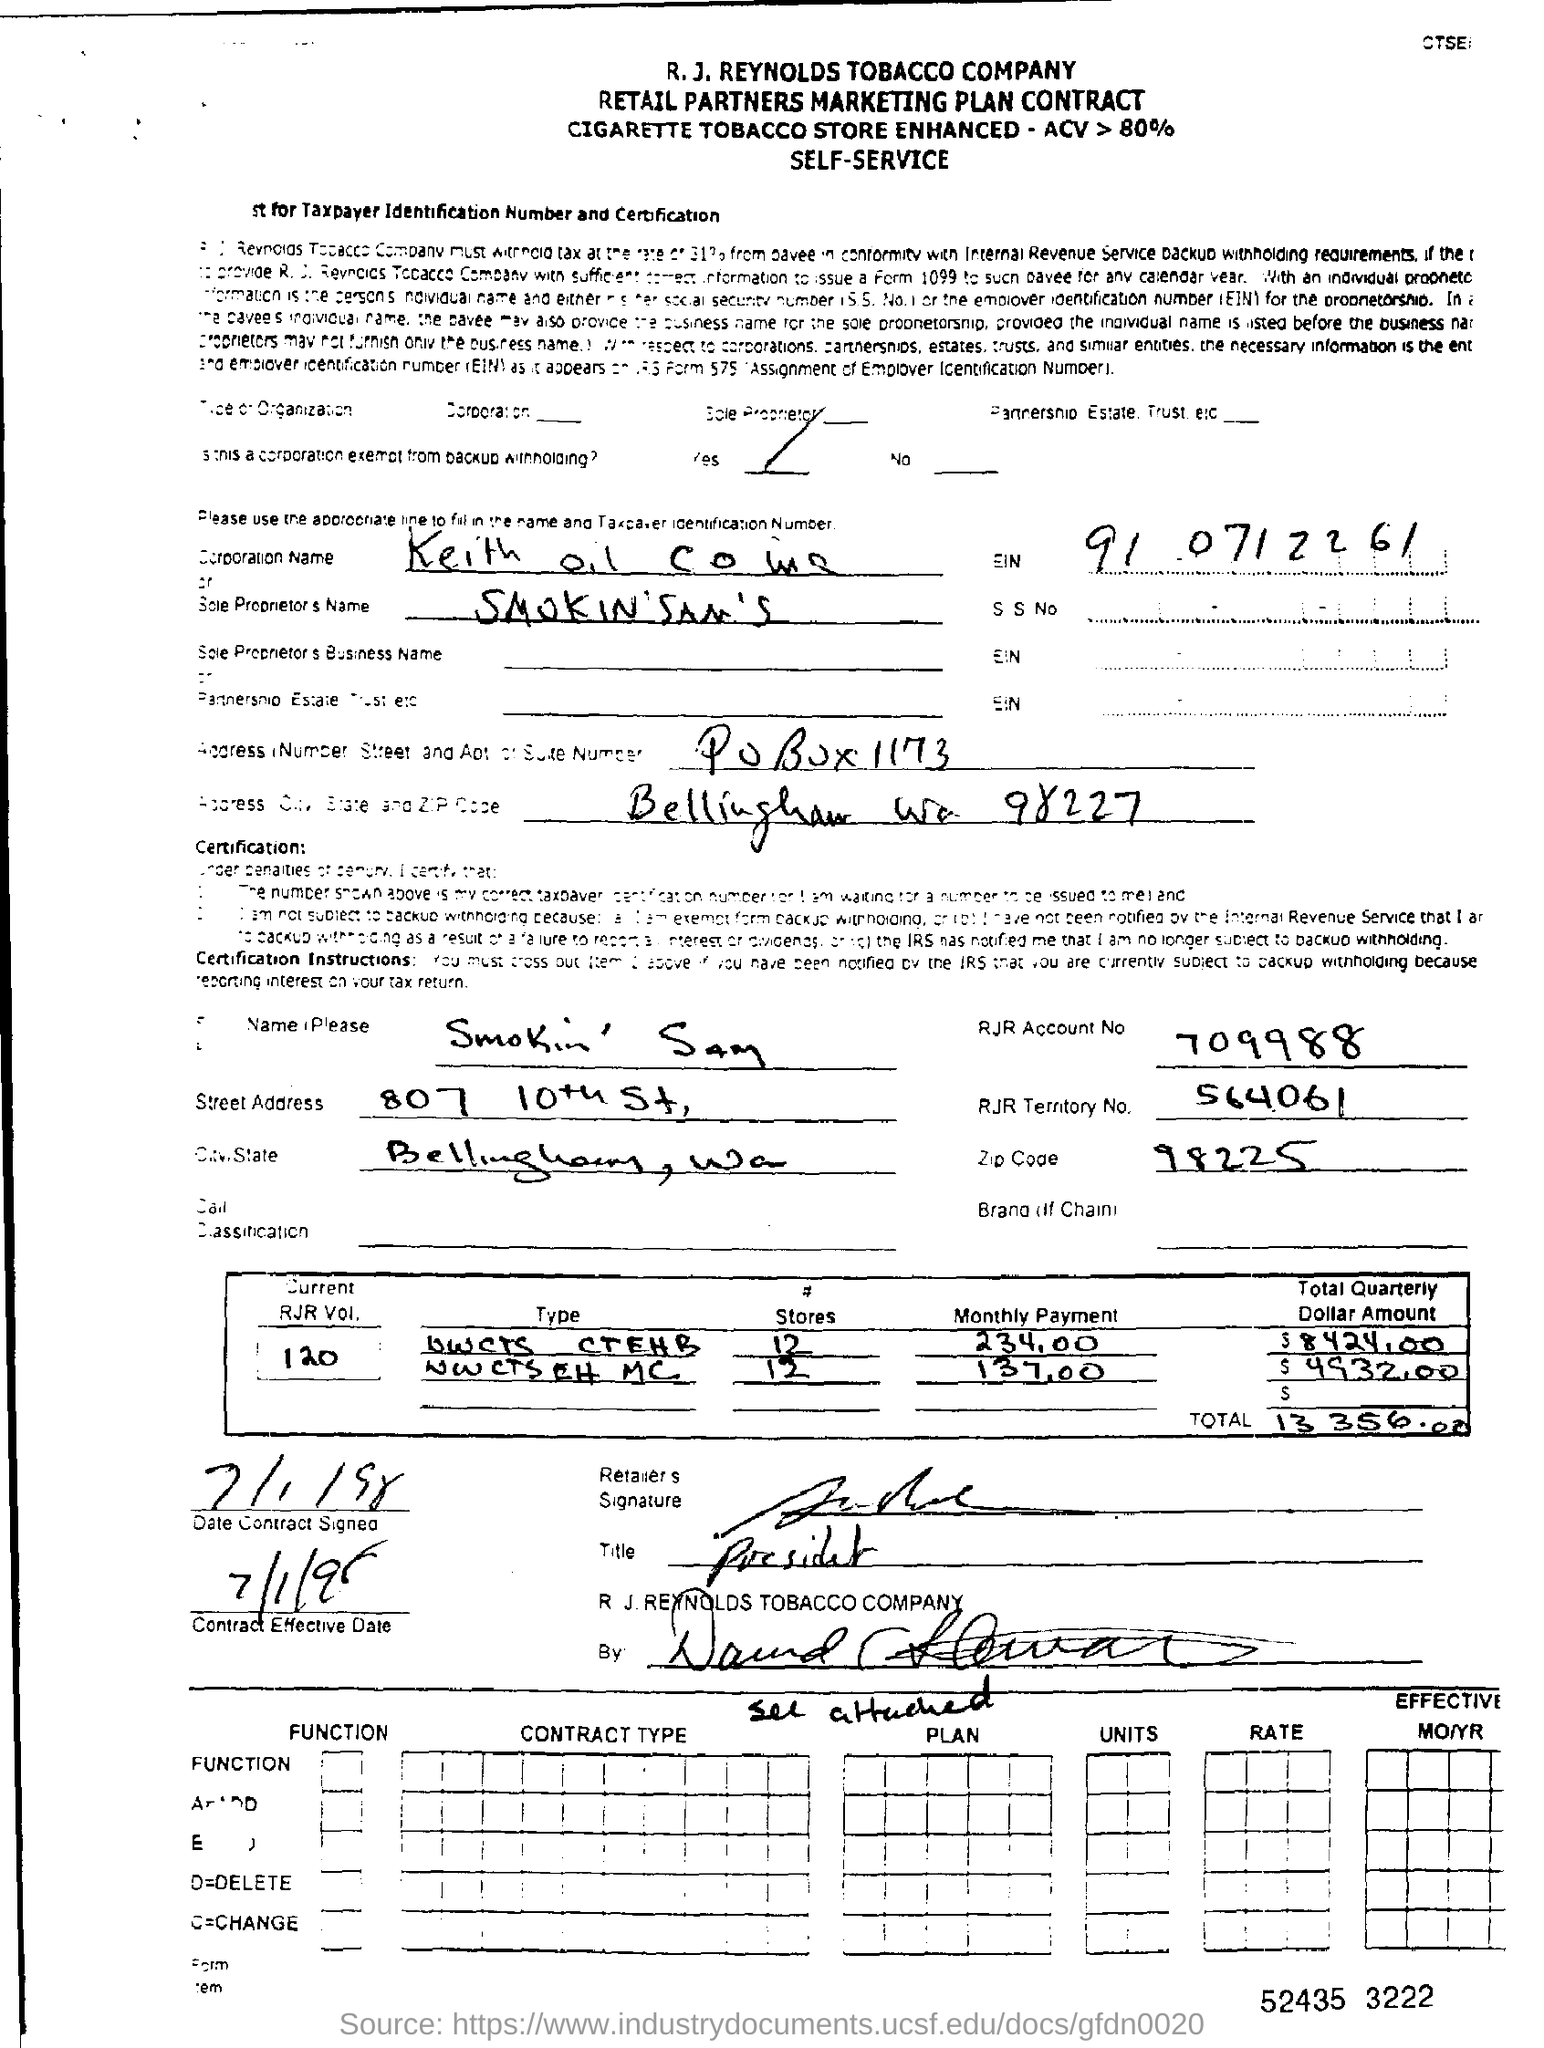What type of contract is this?
Provide a succinct answer. RETAIL PARTNERS MARKETING PLAN CONTRACT. What is the RJR Account No mentioned in the contract form?
Your answer should be very brief. 709988. What is the RJR territory No. mentioned in the contract form?
Your response must be concise. 564061. What is the Date of contract Signed?
Keep it short and to the point. 7/1/98. What is the current RJR Vol. no. mentioned in the contract?
Your response must be concise. 120. What is the total amount mentioned in the contract?
Make the answer very short. 13 356.00. 